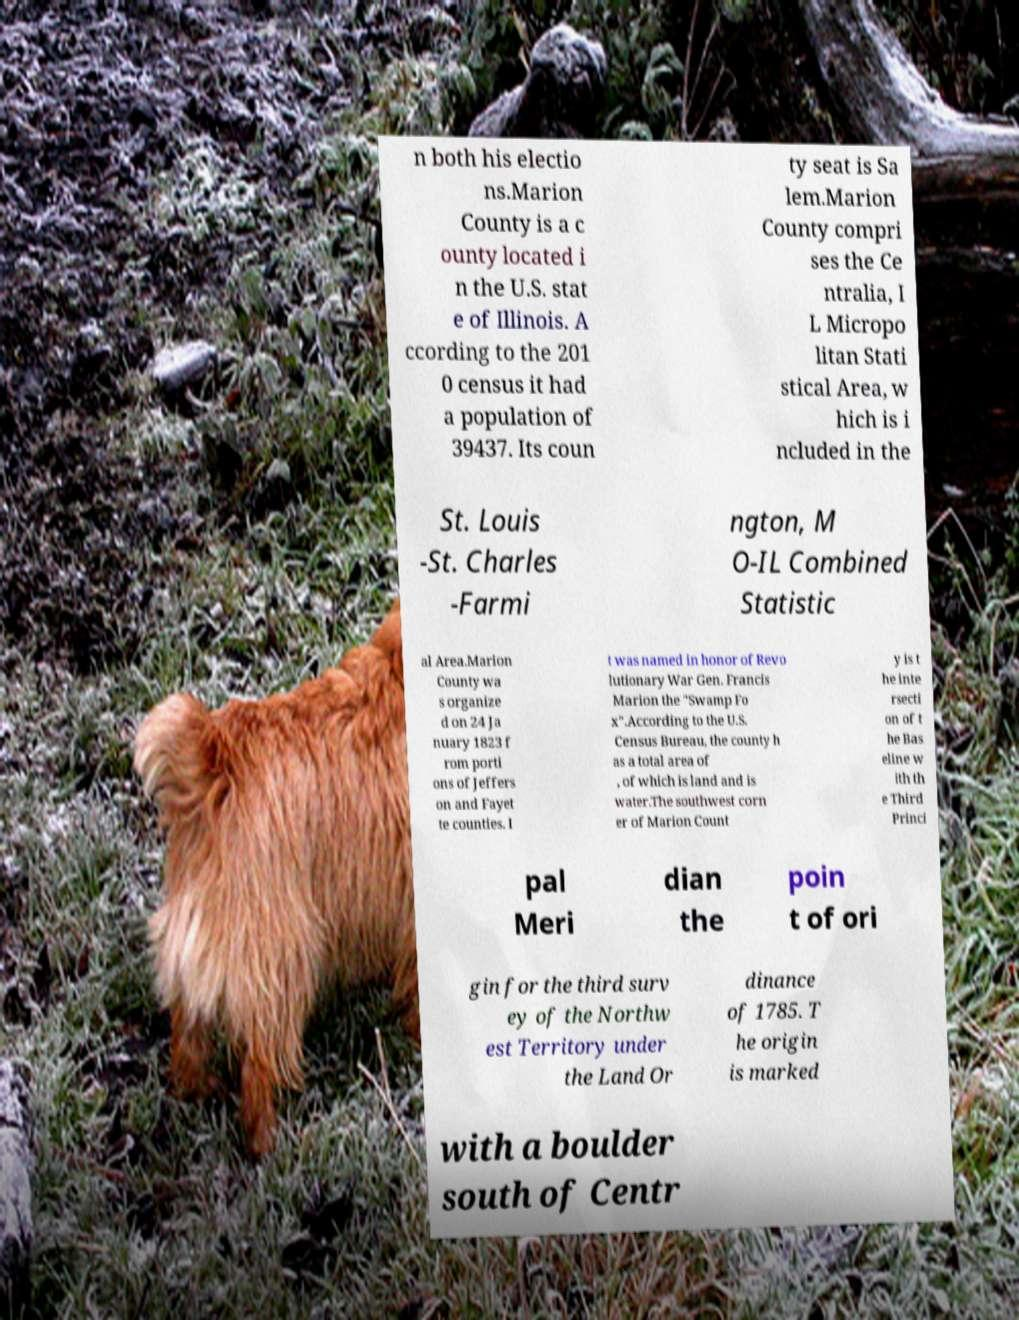Can you accurately transcribe the text from the provided image for me? n both his electio ns.Marion County is a c ounty located i n the U.S. stat e of Illinois. A ccording to the 201 0 census it had a population of 39437. Its coun ty seat is Sa lem.Marion County compri ses the Ce ntralia, I L Micropo litan Stati stical Area, w hich is i ncluded in the St. Louis -St. Charles -Farmi ngton, M O-IL Combined Statistic al Area.Marion County wa s organize d on 24 Ja nuary 1823 f rom porti ons of Jeffers on and Fayet te counties. I t was named in honor of Revo lutionary War Gen. Francis Marion the "Swamp Fo x".According to the U.S. Census Bureau, the county h as a total area of , of which is land and is water.The southwest corn er of Marion Count y is t he inte rsecti on of t he Bas eline w ith th e Third Princi pal Meri dian the poin t of ori gin for the third surv ey of the Northw est Territory under the Land Or dinance of 1785. T he origin is marked with a boulder south of Centr 